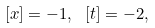<formula> <loc_0><loc_0><loc_500><loc_500>\left [ { x } \right ] = - 1 , \ \left [ t \right ] = - 2 ,</formula> 